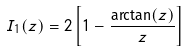<formula> <loc_0><loc_0><loc_500><loc_500>I _ { 1 } ( z ) = 2 \left [ 1 - \frac { \arctan ( z ) } { z } \right ]</formula> 